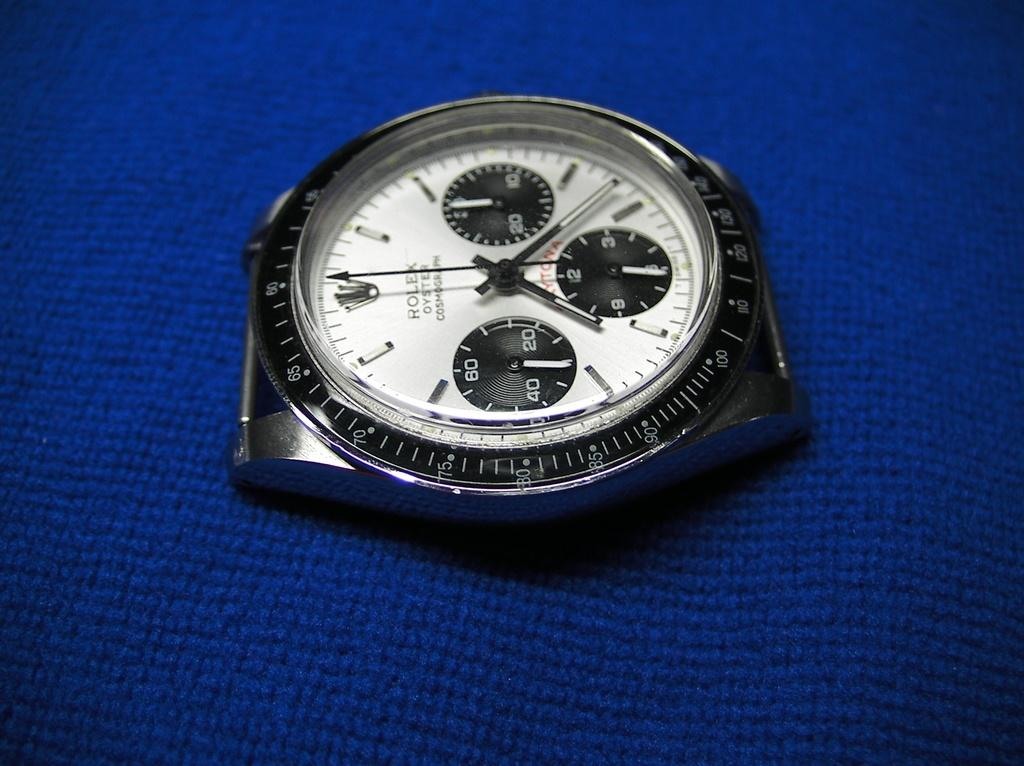<image>
Relay a brief, clear account of the picture shown. A Rolex watch without a band is laying a a piece of blue material. 